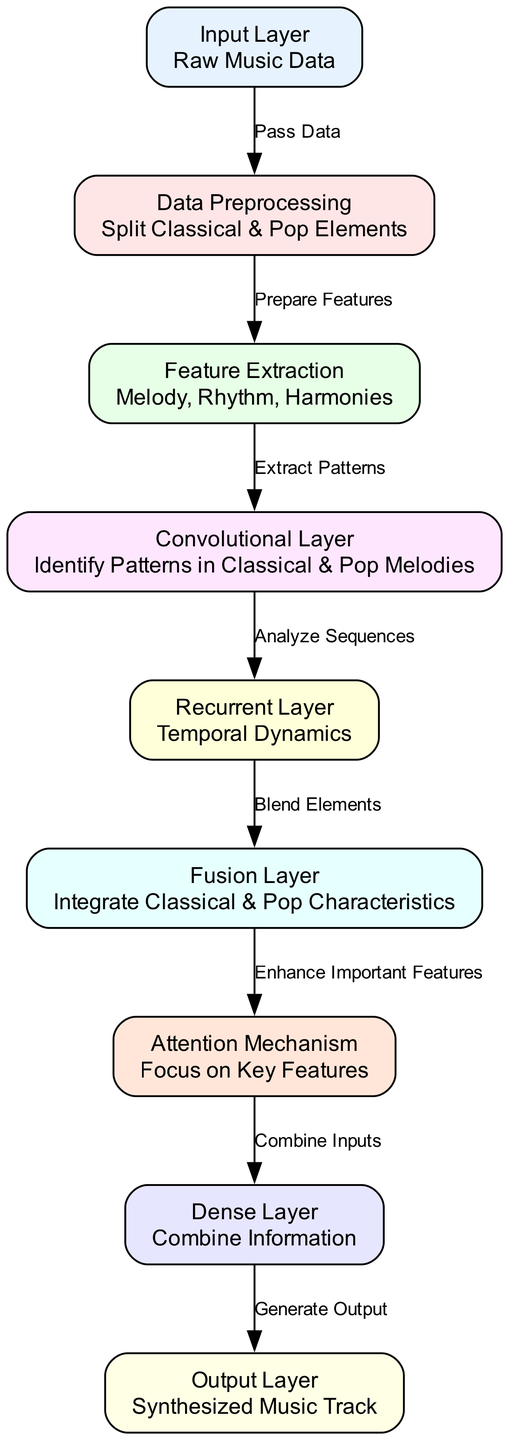What is the label of the first node? The first node in the diagram is labeled "Input Layer".
Answer: Input Layer How many layers are in the diagram? There are 9 nodes that represent different layers in the neural network architecture.
Answer: 9 Which layer comes after the "Data Preprocessing" layer? The layer that comes after "Data Preprocessing" is "Feature Extraction".
Answer: Feature Extraction What type of layer is the "Fusion Layer"? The "Fusion Layer" is an integration layer that combines classical and pop characteristics.
Answer: Integration layer What is the function of the "Attention Mechanism"? The "Attention Mechanism" focuses on identifying and enhancing key features in the synthesized music.
Answer: Focus on Key Features What edge connects the "Convolutional Layer" to the "Recurrent Layer"? The edge connecting these two layers is labeled "Analyze Sequences".
Answer: Analyze Sequences How does the "Output Layer" relate to the process? The "Output Layer" serves to generate the final synthesized music track based on the processed information from the previous layers.
Answer: Generate Output Which layer works with temporal dynamics? The layer that works with temporal dynamics is the "Recurrent Layer".
Answer: Recurrent Layer What does the "Dense Layer" do? The "Dense Layer" combines information from previous layers before producing the final output.
Answer: Combine Information 